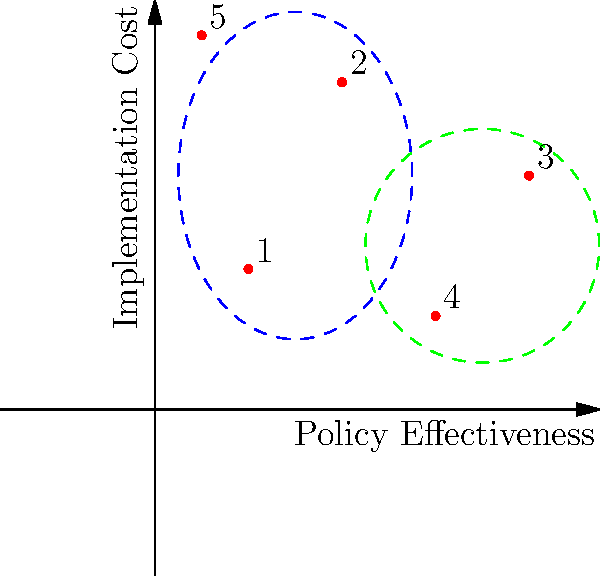Based on the 2D plot showing the relationship between policy effectiveness and implementation cost for various countries' anti-corruption measures, which cluster of countries would be most appealing to a Romanian resident supporting anti-corruption initiatives, and why? To answer this question, we need to analyze the plot and consider the perspective of a Romanian resident who supports anti-corruption measures. Let's break it down step-by-step:

1. Understand the axes:
   - X-axis represents Policy Effectiveness (higher is better)
   - Y-axis represents Implementation Cost (lower is better)

2. Identify the clusters:
   - Blue dashed ellipse: Countries 1, 2, and 5
   - Green dashed ellipse: Countries 3 and 4

3. Analyze the clusters:
   - Blue cluster: 
     * Generally lower effectiveness
     * Varying implementation costs (low to high)
   - Green cluster:
     * Higher effectiveness
     * Lower to medium implementation costs

4. Consider the Romanian perspective:
   - As a supporter of anti-corruption measures, the focus would be on effectiveness
   - Cost is important, but secondary to achieving results

5. Evaluate the best option:
   - The green cluster (countries 3 and 4) shows higher effectiveness
   - It also has moderate to low implementation costs
   - This combination is more appealing for achieving anti-corruption goals

Therefore, the green cluster, containing countries 3 and 4, would be most appealing to a Romanian resident supporting anti-corruption initiatives. It offers the best balance of high effectiveness and reasonable implementation costs.
Answer: Green cluster (countries 3 and 4) 